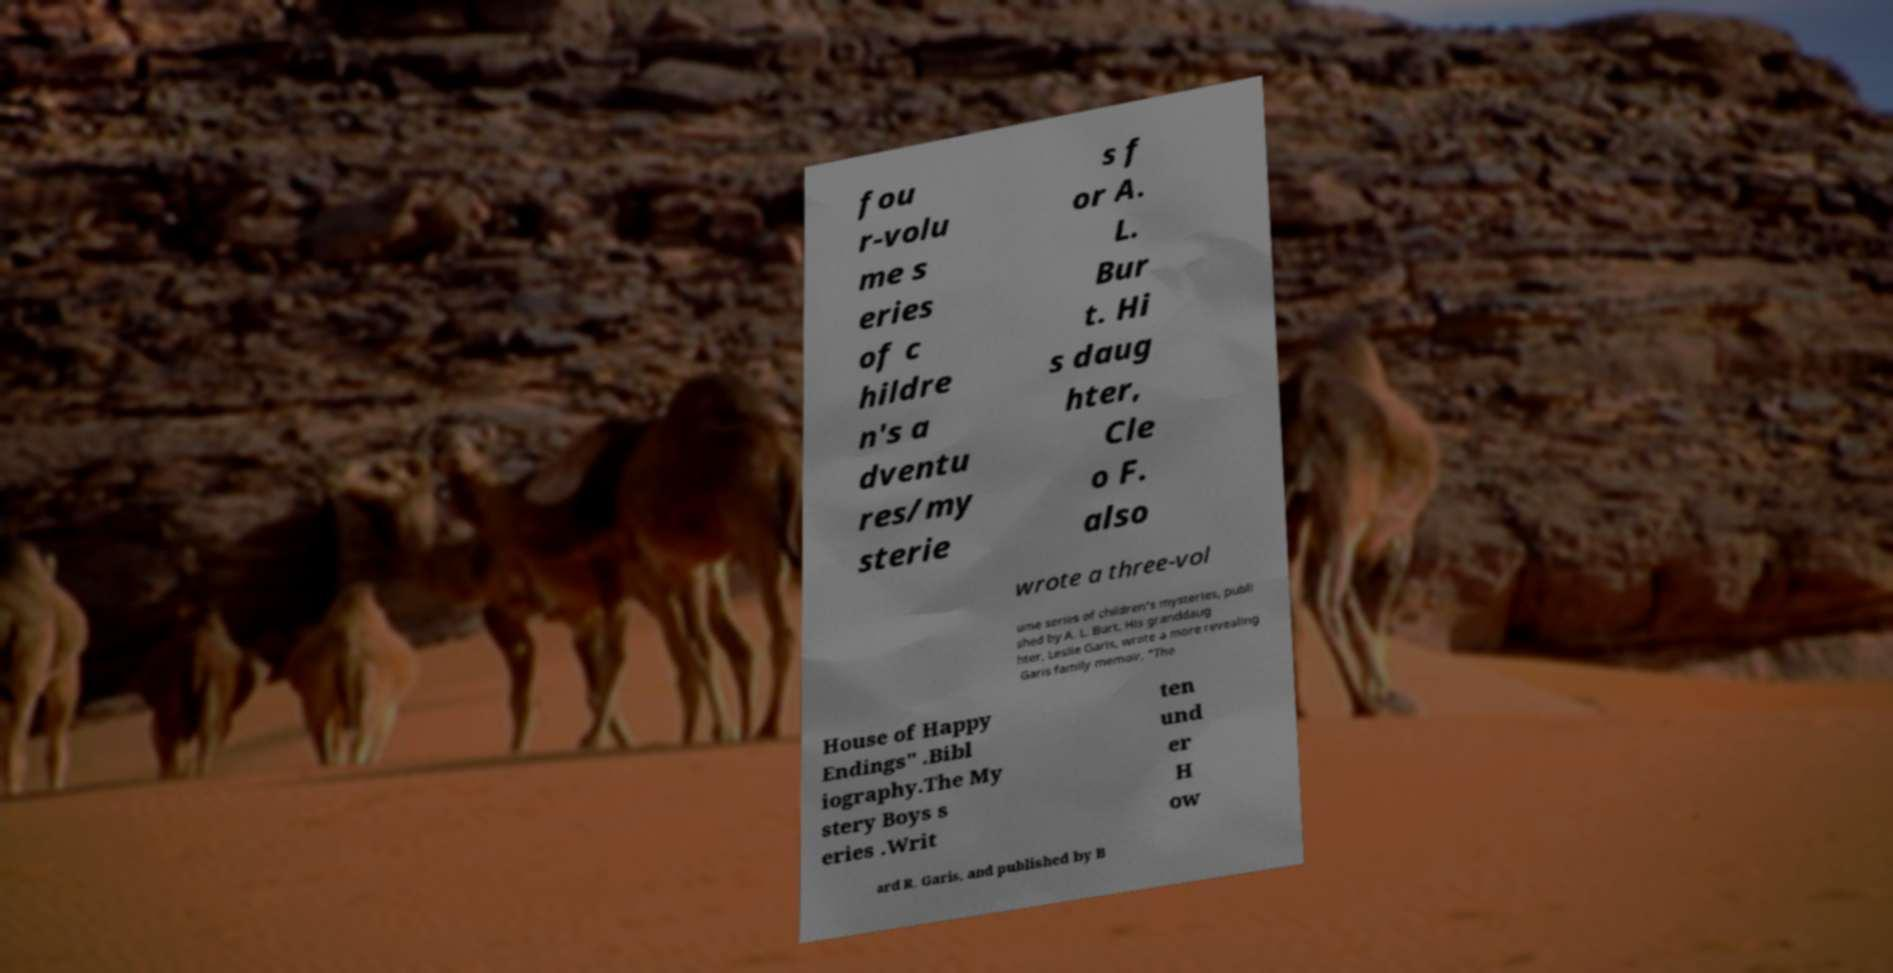There's text embedded in this image that I need extracted. Can you transcribe it verbatim? fou r-volu me s eries of c hildre n's a dventu res/my sterie s f or A. L. Bur t. Hi s daug hter, Cle o F. also wrote a three-vol ume series of children's mysteries, publi shed by A. L. Burt. His granddaug hter, Leslie Garis, wrote a more revealing Garis family memoir, "The House of Happy Endings" .Bibl iography.The My stery Boys s eries .Writ ten und er H ow ard R. Garis, and published by B 